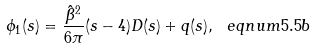<formula> <loc_0><loc_0><loc_500><loc_500>\phi _ { 1 } ( s ) = \frac { \hat { \beta } ^ { 2 } } { 6 \pi } ( s - 4 ) D ( s ) + q ( s ) , \ e q n u m { 5 . 5 b }</formula> 